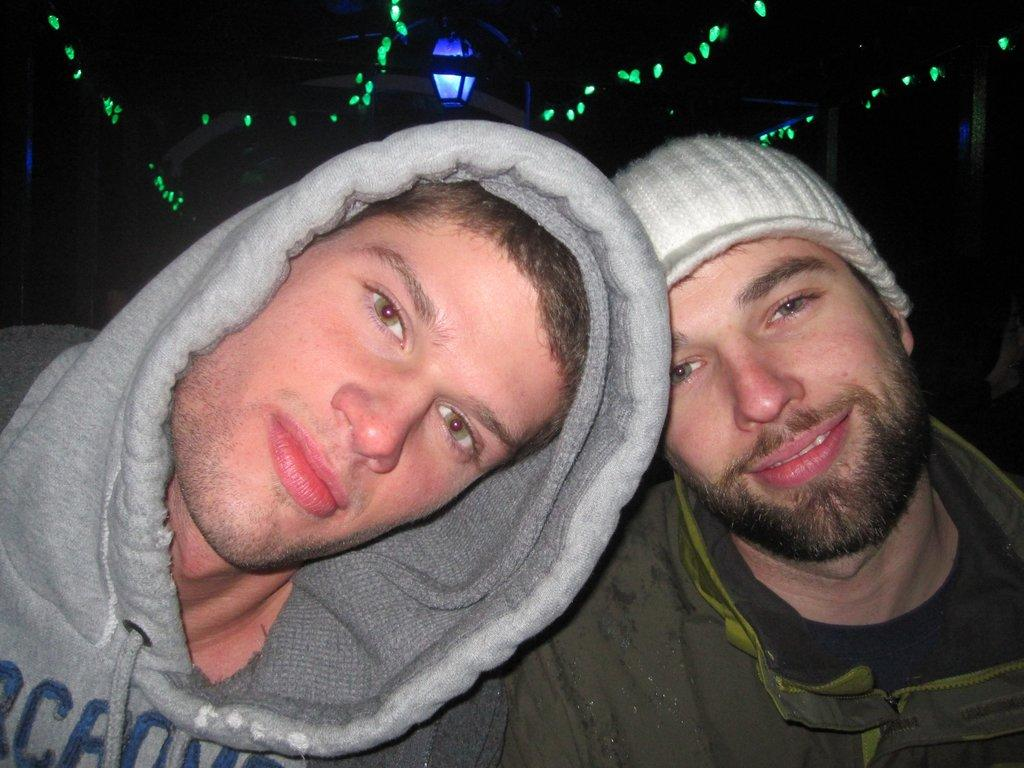How many people are in the image? There are two men in the image. What is the facial expression of the men in the image? Both men are smiling. Can you describe the clothing of one of the men? One man is wearing a cap. What can be seen in the background of the image? There are lights visible in the background. How would you describe the lighting conditions in the image? The background appears to be dark. What type of vegetable is being chopped by the man with the hammer in the image? There is no man with a hammer or any vegetable present in the image. 